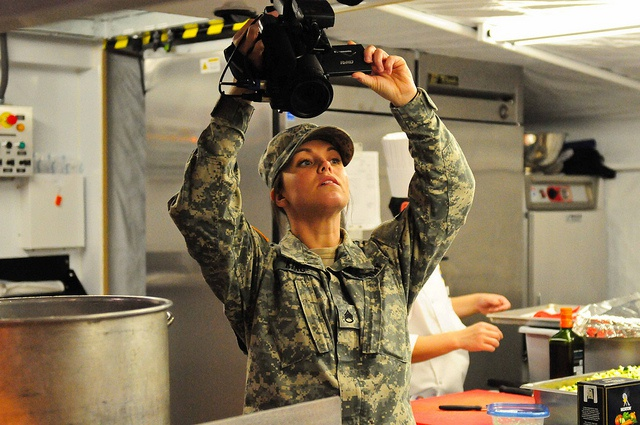Describe the objects in this image and their specific colors. I can see people in maroon, black, tan, olive, and gray tones, refrigerator in maroon, tan, and gray tones, people in maroon, ivory, tan, orange, and red tones, bottle in maroon, black, red, darkgreen, and gray tones, and bowl in maroon, tan, darkgray, and gray tones in this image. 